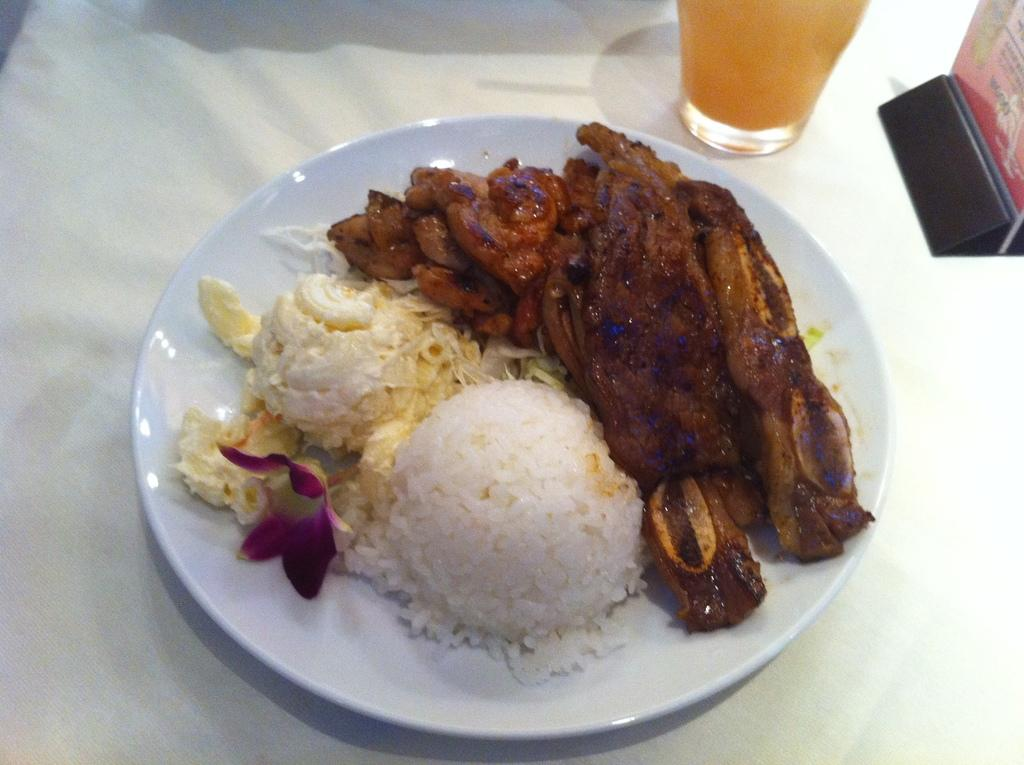What is on the white plate in the image? There are food items and a flower on the white plate in the image. What is the color of the cloth that the plate is placed on? The plate is placed on a white cloth. What can be seen in the top part of the image? There is a glass and additional objects visible in the top part of the image. What type of linen is used to cover the table in the image? There is no linen visible in the image; only a white cloth is mentioned. What thoughts are the food items having in the image? Food items do not have thoughts, as they are inanimate objects. 